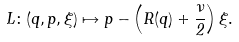<formula> <loc_0><loc_0><loc_500><loc_500>L \colon ( q , p , \xi ) \mapsto p - \left ( R ( q ) + \frac { \nu } { 2 } \right ) \xi .</formula> 